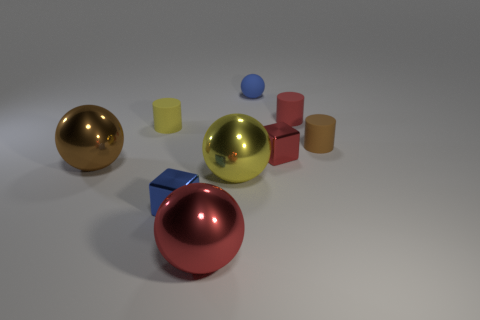There is a rubber thing that is the same shape as the large yellow shiny thing; what is its color?
Offer a terse response. Blue. What number of objects have the same color as the rubber ball?
Ensure brevity in your answer.  1. How big is the brown metallic sphere?
Make the answer very short. Large. Is the size of the matte ball the same as the yellow metallic thing?
Your answer should be very brief. No. There is a rubber object that is to the right of the red ball and on the left side of the small red cylinder; what is its color?
Ensure brevity in your answer.  Blue. How many large blue cubes are the same material as the red cylinder?
Provide a short and direct response. 0. How many small metallic cylinders are there?
Provide a short and direct response. 0. Does the blue matte object have the same size as the red shiny thing on the left side of the small blue sphere?
Your response must be concise. No. There is a blue thing left of the tiny object behind the small red matte thing; what is it made of?
Your response must be concise. Metal. How big is the cube that is to the right of the big metallic sphere in front of the blue cube in front of the tiny red matte cylinder?
Your answer should be compact. Small. 